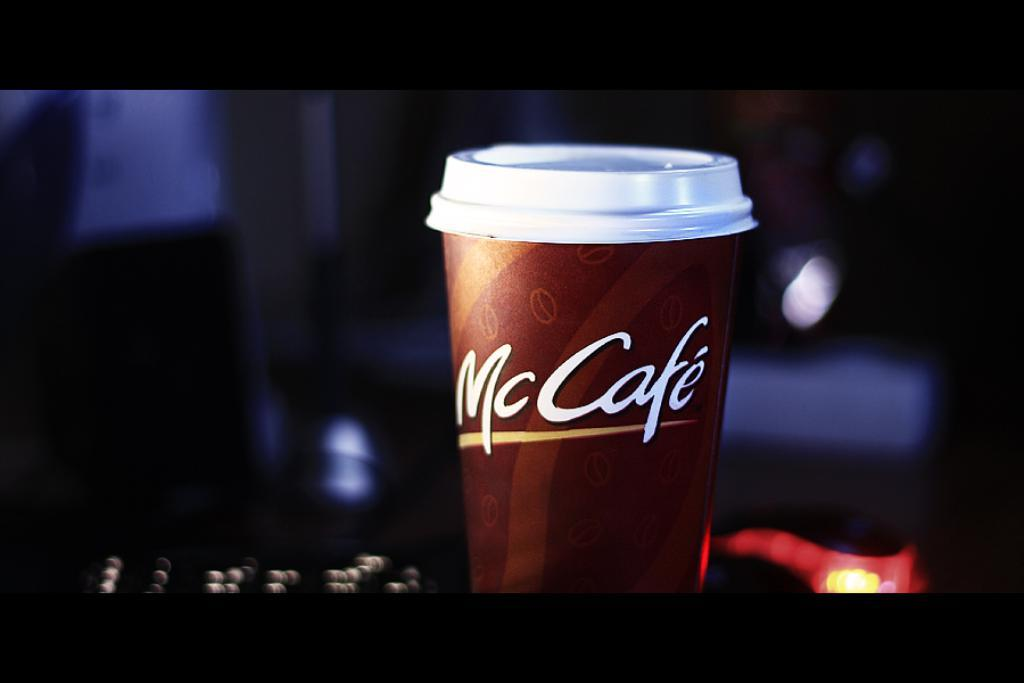<image>
Describe the image concisely. An ad or picture of a mccafe coffee with the white lid on top. 